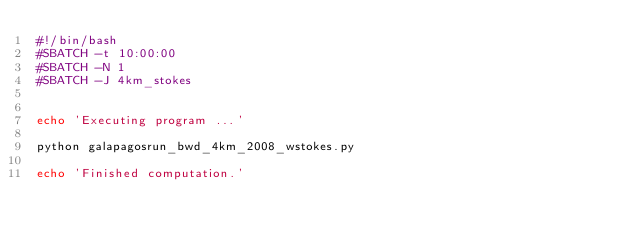<code> <loc_0><loc_0><loc_500><loc_500><_Bash_>#!/bin/bash
#SBATCH -t 10:00:00
#SBATCH -N 1
#SBATCH -J 4km_stokes


echo 'Executing program ...'

python galapagosrun_bwd_4km_2008_wstokes.py

echo 'Finished computation.'
</code> 